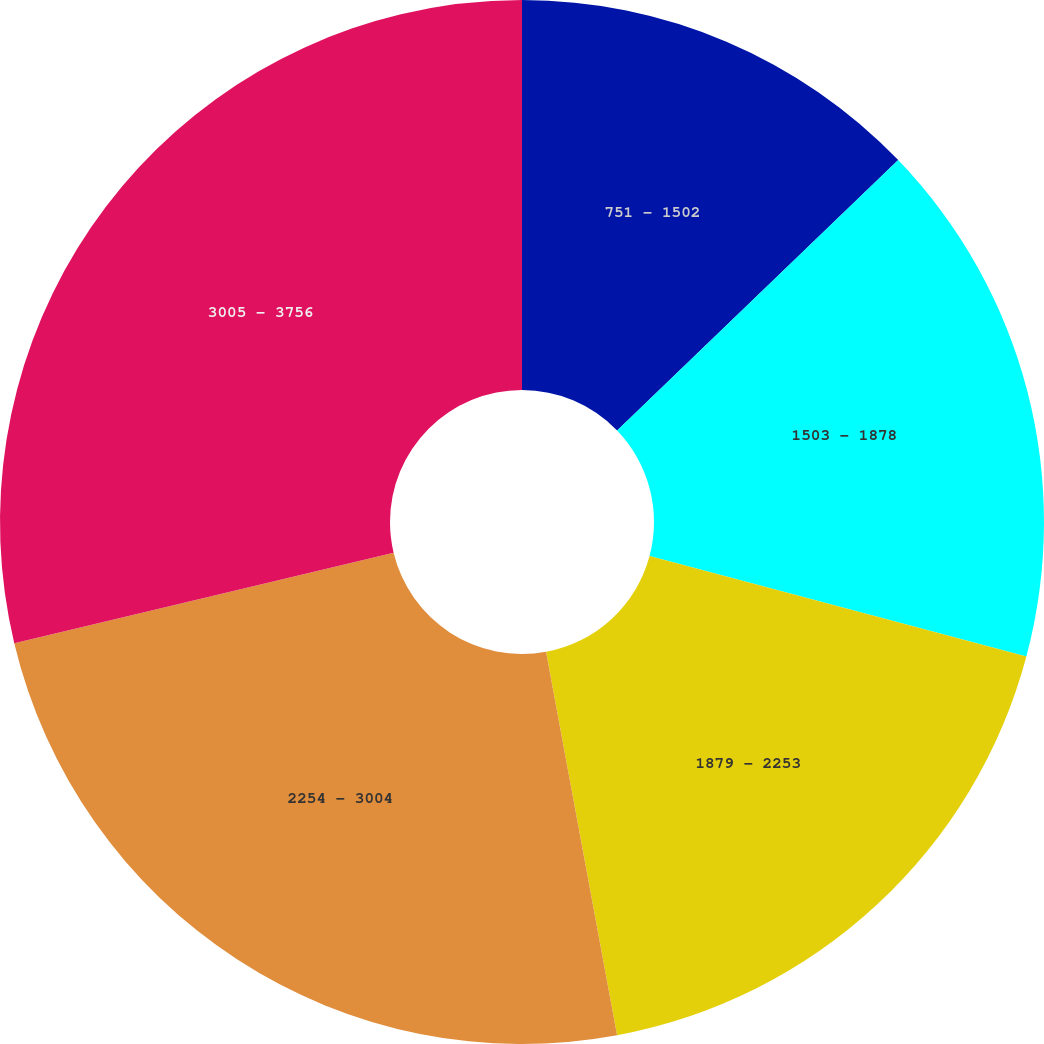Convert chart. <chart><loc_0><loc_0><loc_500><loc_500><pie_chart><fcel>751 - 1502<fcel>1503 - 1878<fcel>1879 - 2253<fcel>2254 - 3004<fcel>3005 - 3756<nl><fcel>12.81%<fcel>16.34%<fcel>17.94%<fcel>24.19%<fcel>28.73%<nl></chart> 